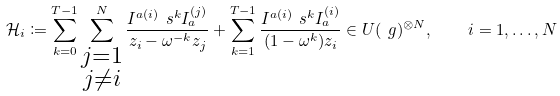Convert formula to latex. <formula><loc_0><loc_0><loc_500><loc_500>\mathcal { H } _ { i } \coloneqq \sum _ { k = 0 } ^ { T - 1 } \sum _ { \substack { j = 1 \\ j \neq i } } ^ { N } \frac { I ^ { a ( i ) } \ s ^ { k } I _ { a } ^ { ( j ) } } { z _ { i } - \omega ^ { - k } z _ { j } } + \sum _ { k = 1 } ^ { T - 1 } \frac { I ^ { a ( i ) } \ s ^ { k } I _ { a } ^ { ( i ) } } { ( 1 - \omega ^ { k } ) z _ { i } } \in U ( \ g ) ^ { \otimes N } , \quad i = 1 , \dots , N</formula> 